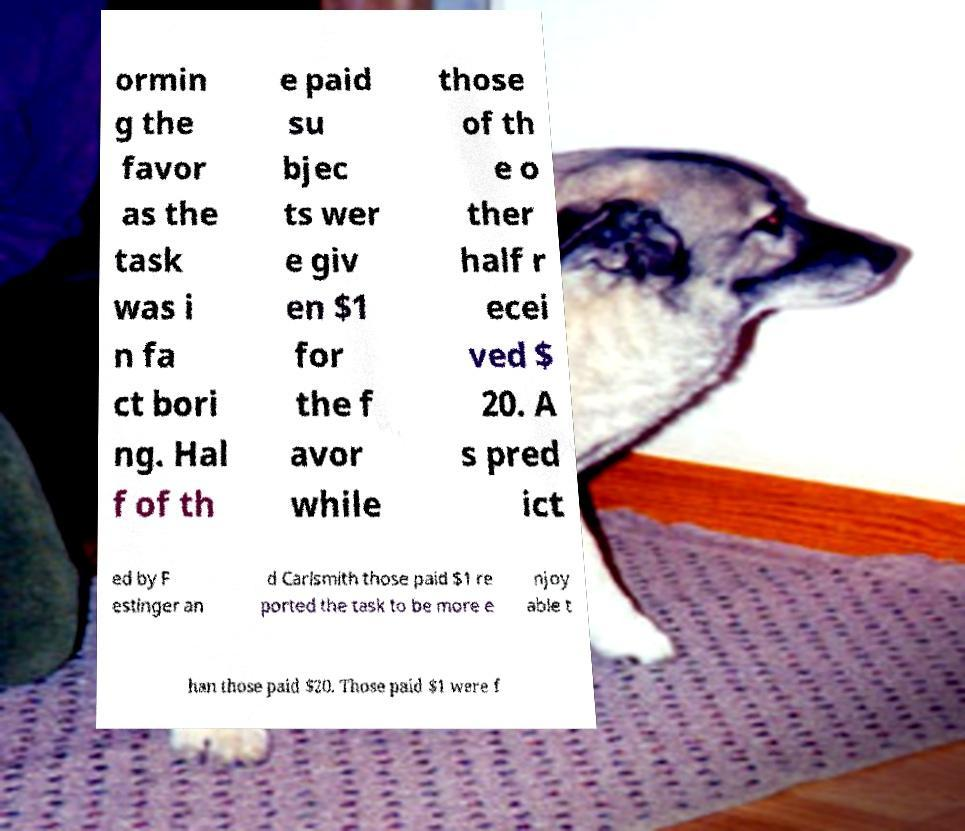For documentation purposes, I need the text within this image transcribed. Could you provide that? ormin g the favor as the task was i n fa ct bori ng. Hal f of th e paid su bjec ts wer e giv en $1 for the f avor while those of th e o ther half r ecei ved $ 20. A s pred ict ed by F estinger an d Carlsmith those paid $1 re ported the task to be more e njoy able t han those paid $20. Those paid $1 were f 